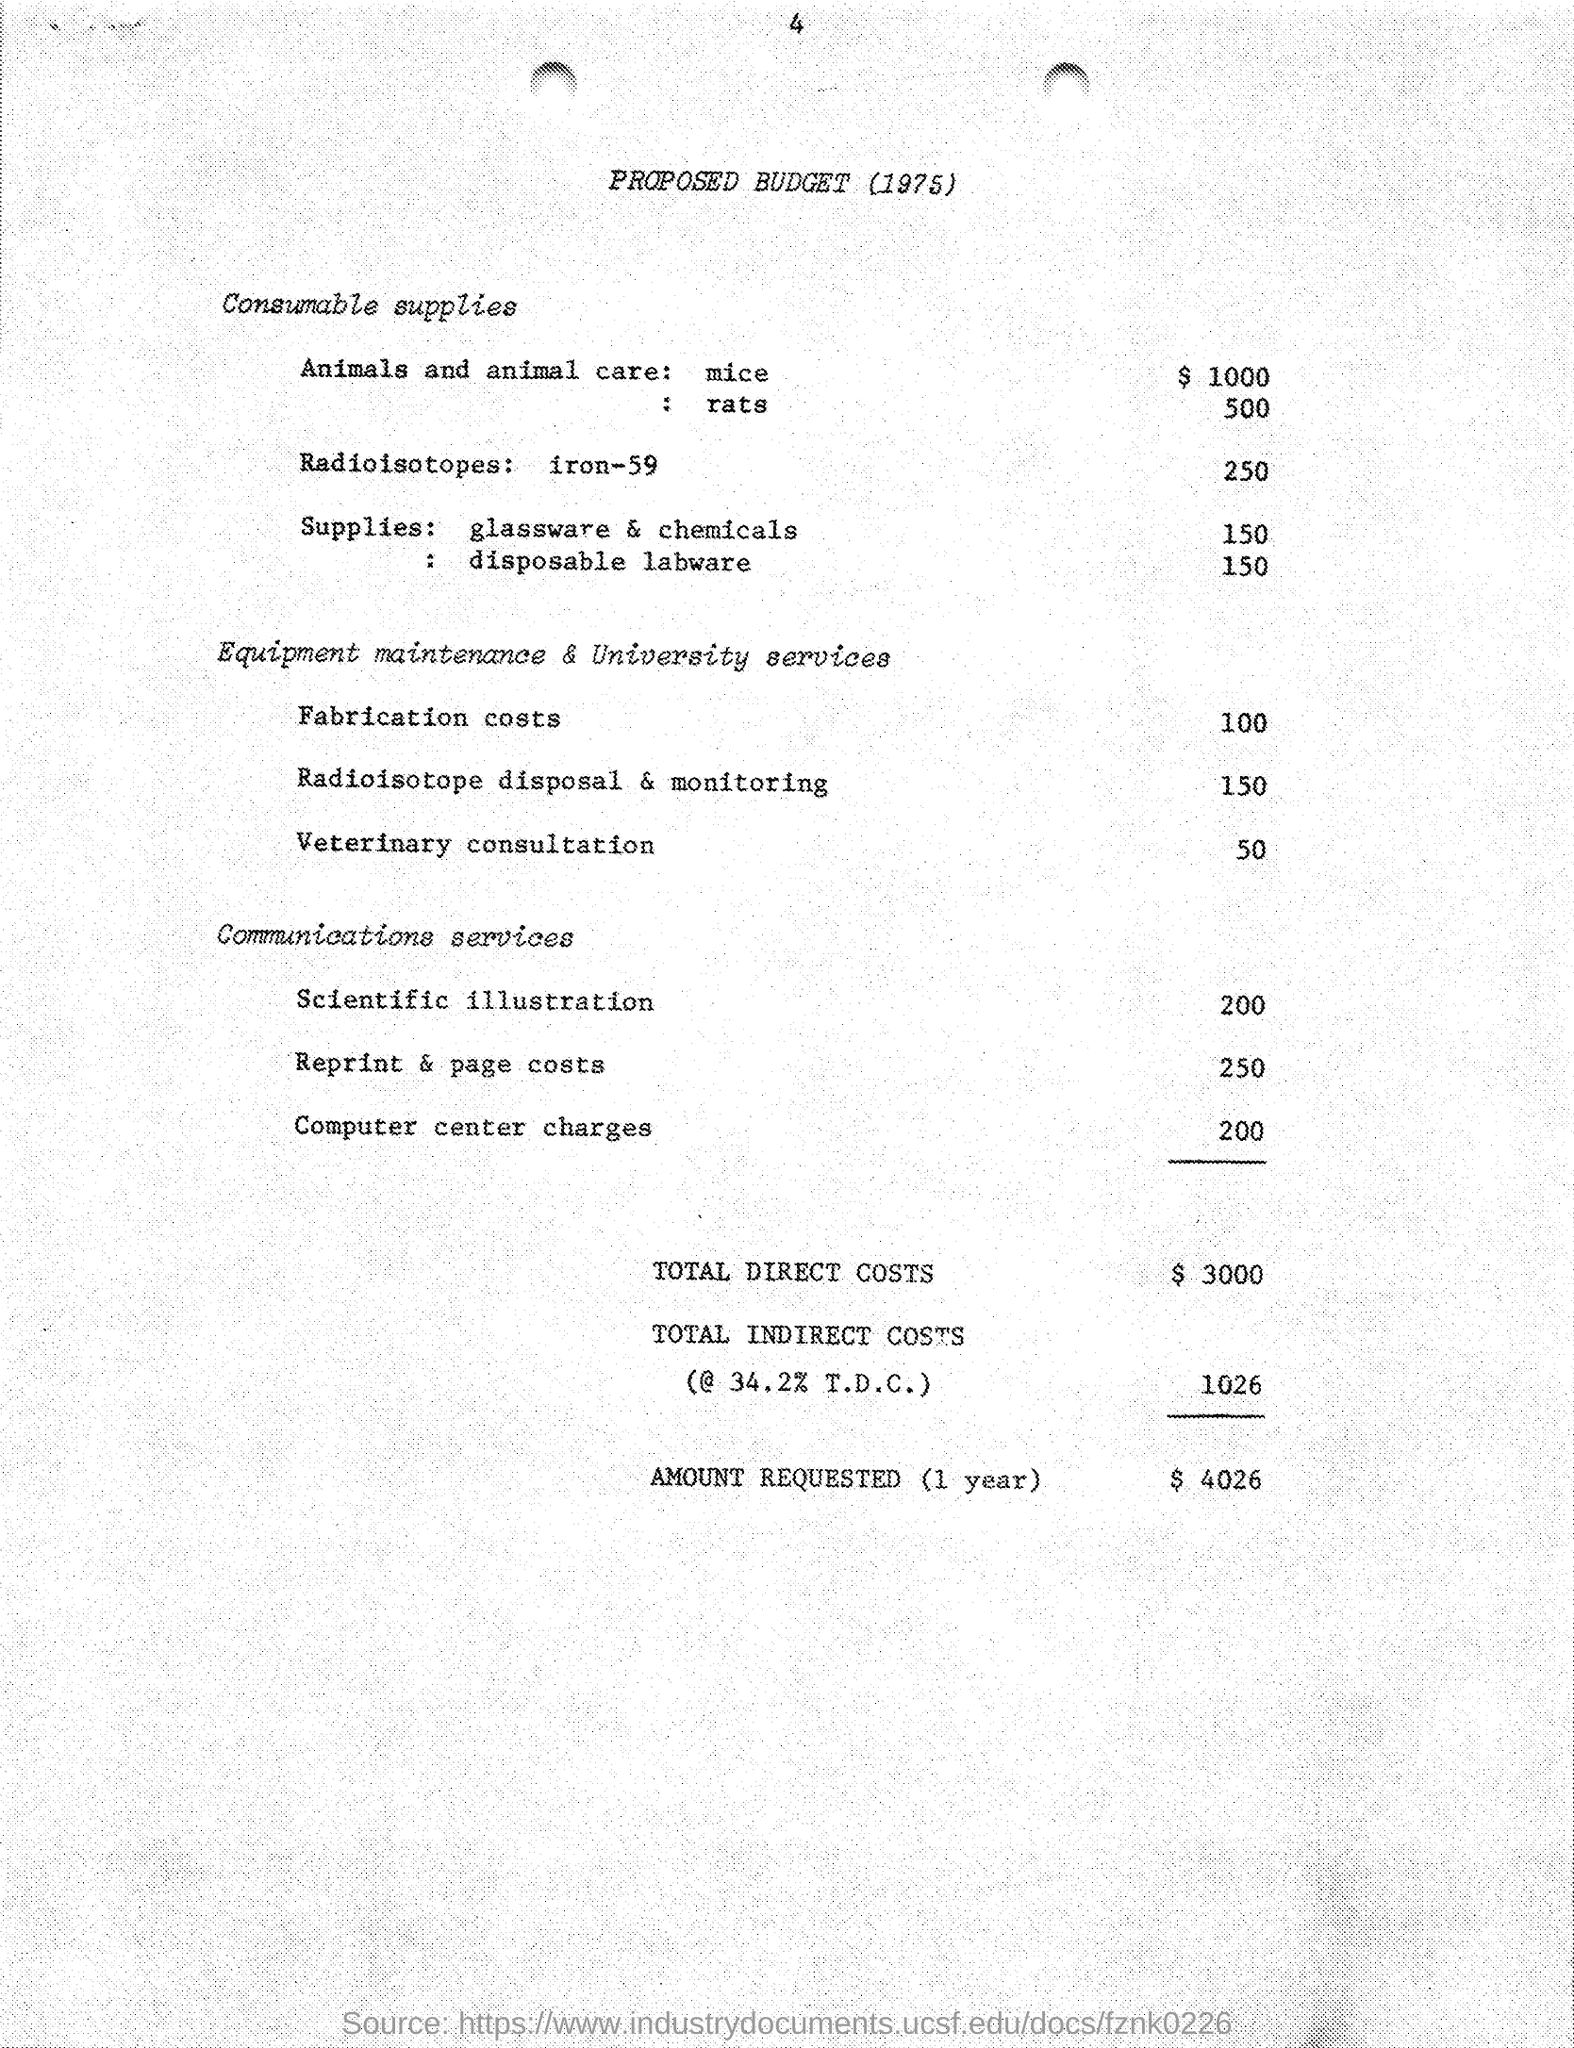Mention a couple of crucial points in this snapshot. The proposed budget includes $100 for fabrication costs. The proposed budget includes an allocation of $500 for the care of animals, specifically rats. The proposed budget includes an amount of $250 for radioisotopes: iron -59. The proposed budget includes an amount for reprint and page costs, which is 250. The proposed budget includes an allocation of $1,000 for the care of animals, specifically mice. 